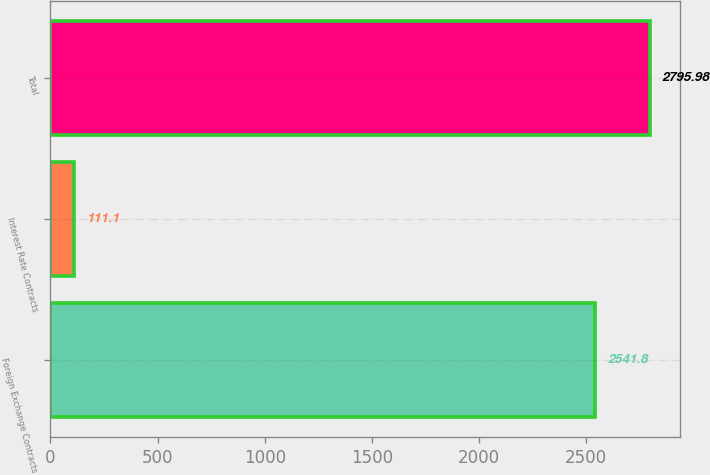Convert chart to OTSL. <chart><loc_0><loc_0><loc_500><loc_500><bar_chart><fcel>Foreign Exchange Contracts<fcel>Interest Rate Contracts<fcel>Total<nl><fcel>2541.8<fcel>111.1<fcel>2795.98<nl></chart> 